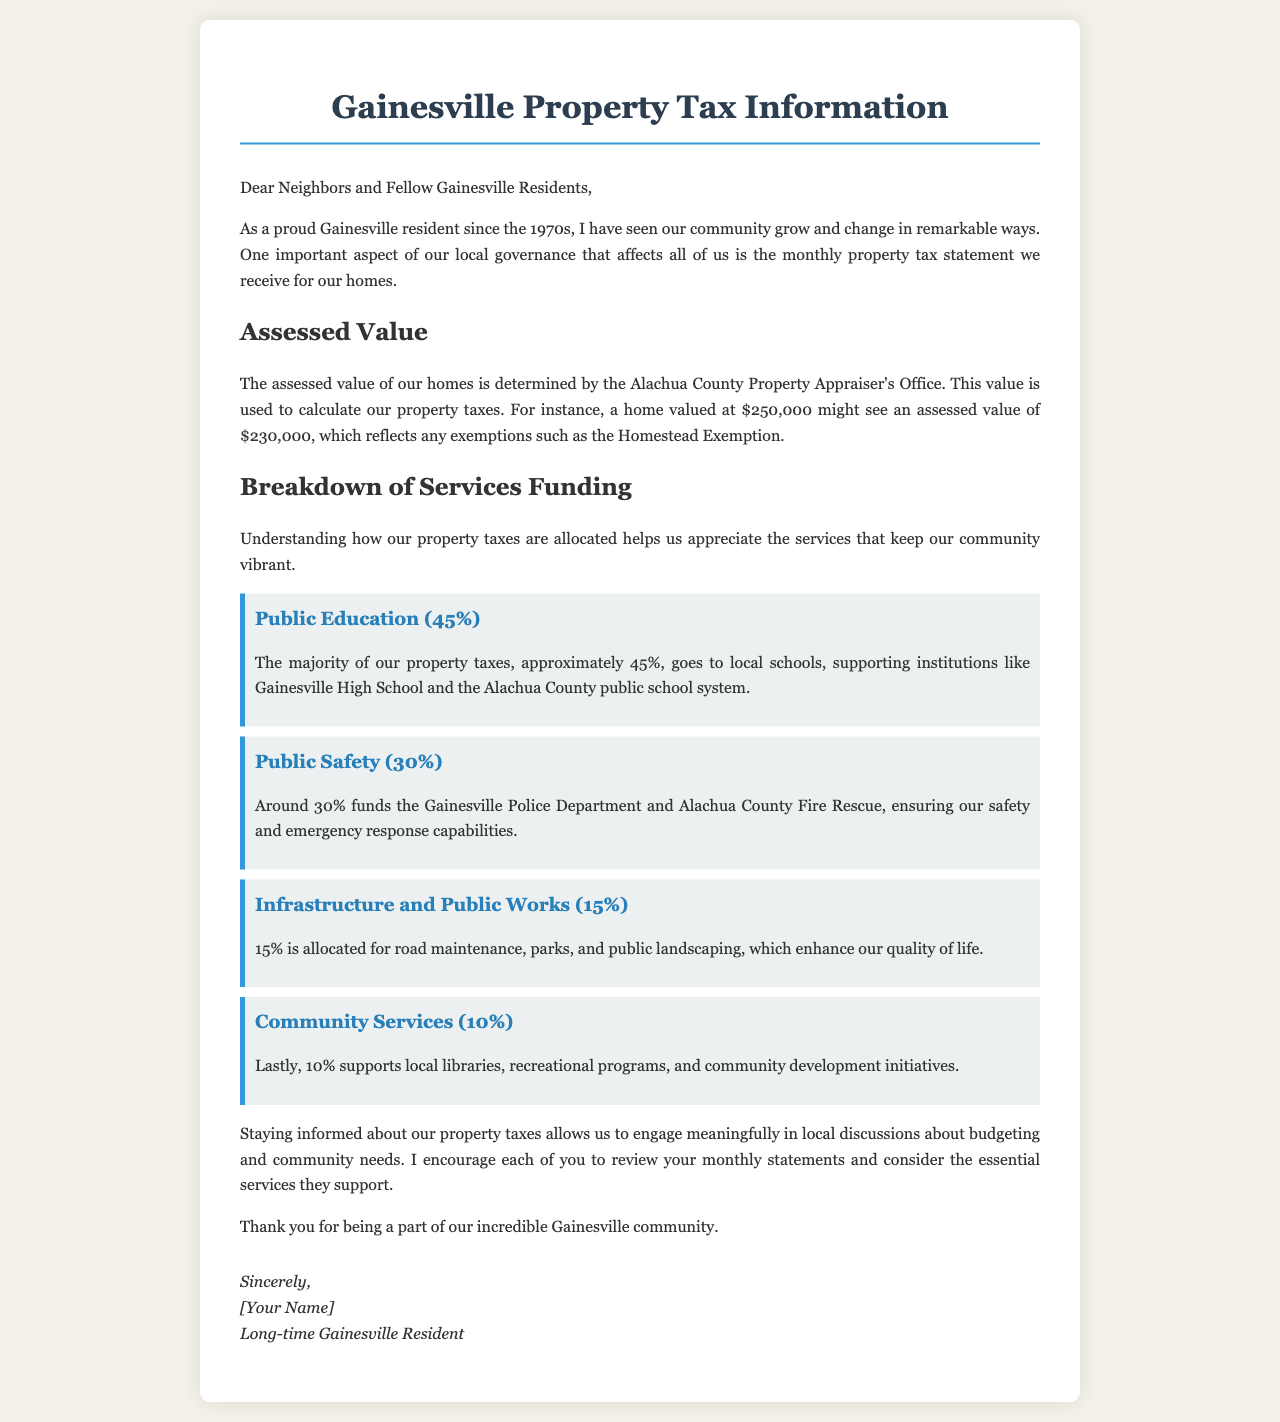What is the assessed value of a home valued at $250,000? The assessed value is calculated as $250,000 minus any exemptions, resulting in an assessed value of $230,000.
Answer: $230,000 How much of the property tax goes to public education? The document states that approximately 45% of property taxes is allocated to public education.
Answer: 45% What percentage of property taxes is used for public safety? The document explicitly mentions that around 30% funds public safety services.
Answer: 30% What services use 15% of the property taxes? According to the letter, 15% is allocated for infrastructure and public works, including road maintenance and parks.
Answer: Infrastructure and Public Works What is the total percentage of tax funding for community services? The letter states that 10% supports local libraries, recreational programs, and community development initiatives.
Answer: 10% Which department ensures safety and emergency response capabilities? The document identifies the Gainesville Police Department and Alachua County Fire Rescue as the departments that ensure safety.
Answer: Gainesville Police Department and Alachua County Fire Rescue What is the main purpose of reviewing monthly property tax statements? The letter emphasizes that staying informed allows for meaningful engagement in local discussions about budgeting and community needs.
Answer: Engagement in local discussions Who wrote the letter? The document includes a signature section where the writer identifies themselves as a long-time Gainesville resident.
Answer: [Your Name] How long has the writer lived in Gainesville? The writer states that they have lived in the area since the 1970s.
Answer: Since the 1970s 